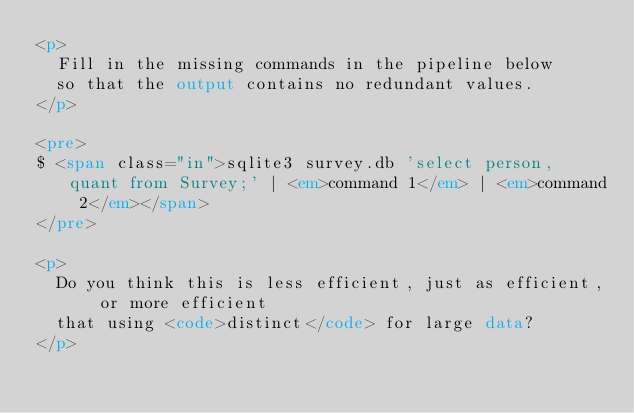Convert code to text. <code><loc_0><loc_0><loc_500><loc_500><_HTML_><p>
  Fill in the missing commands in the pipeline below
  so that the output contains no redundant values.
</p>

<pre>
$ <span class="in">sqlite3 survey.db 'select person, quant from Survey;' | <em>command 1</em> | <em>command 2</em></span>
</pre>

<p>
  Do you think this is less efficient, just as efficient, or more efficient
  that using <code>distinct</code> for large data?
</p>
</code> 